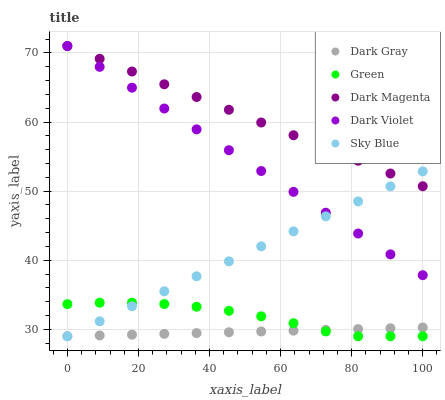Does Dark Gray have the minimum area under the curve?
Answer yes or no. Yes. Does Dark Magenta have the maximum area under the curve?
Answer yes or no. Yes. Does Sky Blue have the minimum area under the curve?
Answer yes or no. No. Does Sky Blue have the maximum area under the curve?
Answer yes or no. No. Is Dark Gray the smoothest?
Answer yes or no. Yes. Is Green the roughest?
Answer yes or no. Yes. Is Sky Blue the smoothest?
Answer yes or no. No. Is Sky Blue the roughest?
Answer yes or no. No. Does Dark Gray have the lowest value?
Answer yes or no. Yes. Does Dark Magenta have the lowest value?
Answer yes or no. No. Does Dark Violet have the highest value?
Answer yes or no. Yes. Does Sky Blue have the highest value?
Answer yes or no. No. Is Green less than Dark Magenta?
Answer yes or no. Yes. Is Dark Magenta greater than Dark Gray?
Answer yes or no. Yes. Does Dark Gray intersect Sky Blue?
Answer yes or no. Yes. Is Dark Gray less than Sky Blue?
Answer yes or no. No. Is Dark Gray greater than Sky Blue?
Answer yes or no. No. Does Green intersect Dark Magenta?
Answer yes or no. No. 